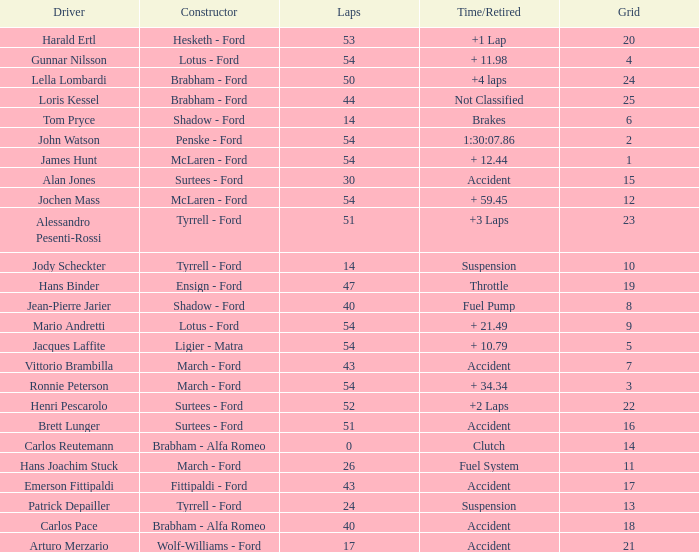How many laps did Emerson Fittipaldi do on a grid larger than 14, and when was the Time/Retired of accident? 1.0. 